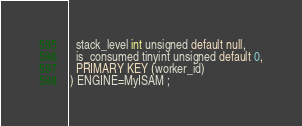<code> <loc_0><loc_0><loc_500><loc_500><_SQL_>  stack_level int unsigned default null,
  is_consumed tinyint unsigned default 0,
  PRIMARY KEY (worker_id)
) ENGINE=MyISAM ;
</code> 